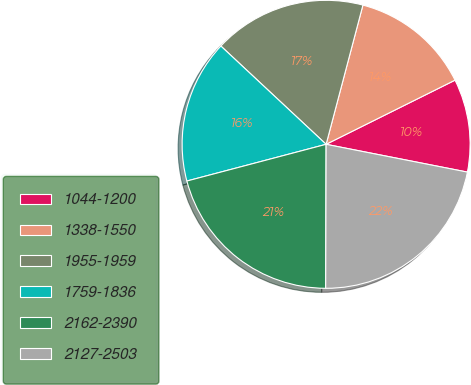Convert chart to OTSL. <chart><loc_0><loc_0><loc_500><loc_500><pie_chart><fcel>1044-1200<fcel>1338-1550<fcel>1955-1959<fcel>1759-1836<fcel>2162-2390<fcel>2127-2503<nl><fcel>10.44%<fcel>13.54%<fcel>17.16%<fcel>16.06%<fcel>20.85%<fcel>21.96%<nl></chart> 